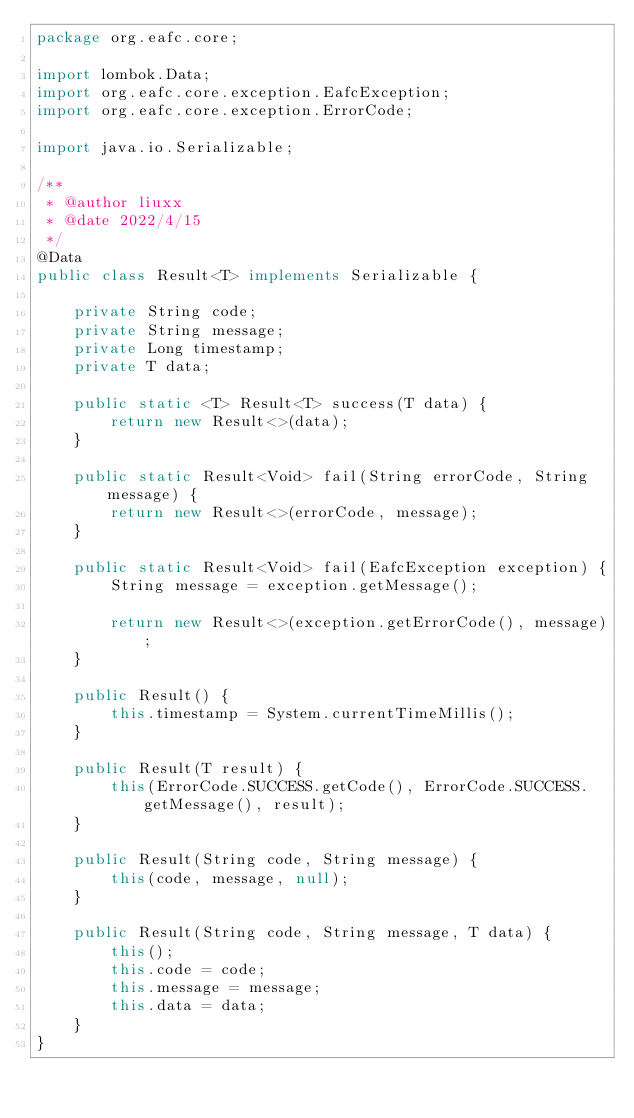Convert code to text. <code><loc_0><loc_0><loc_500><loc_500><_Java_>package org.eafc.core;

import lombok.Data;
import org.eafc.core.exception.EafcException;
import org.eafc.core.exception.ErrorCode;

import java.io.Serializable;

/**
 * @author liuxx
 * @date 2022/4/15
 */
@Data
public class Result<T> implements Serializable {

    private String code;
    private String message;
    private Long timestamp;
    private T data;

    public static <T> Result<T> success(T data) {
        return new Result<>(data);
    }

    public static Result<Void> fail(String errorCode, String message) {
        return new Result<>(errorCode, message);
    }

    public static Result<Void> fail(EafcException exception) {
        String message = exception.getMessage();

        return new Result<>(exception.getErrorCode(), message);
    }

    public Result() {
        this.timestamp = System.currentTimeMillis();
    }

    public Result(T result) {
        this(ErrorCode.SUCCESS.getCode(), ErrorCode.SUCCESS.getMessage(), result);
    }

    public Result(String code, String message) {
        this(code, message, null);
    }

    public Result(String code, String message, T data) {
        this();
        this.code = code;
        this.message = message;
        this.data = data;
    }
}
</code> 